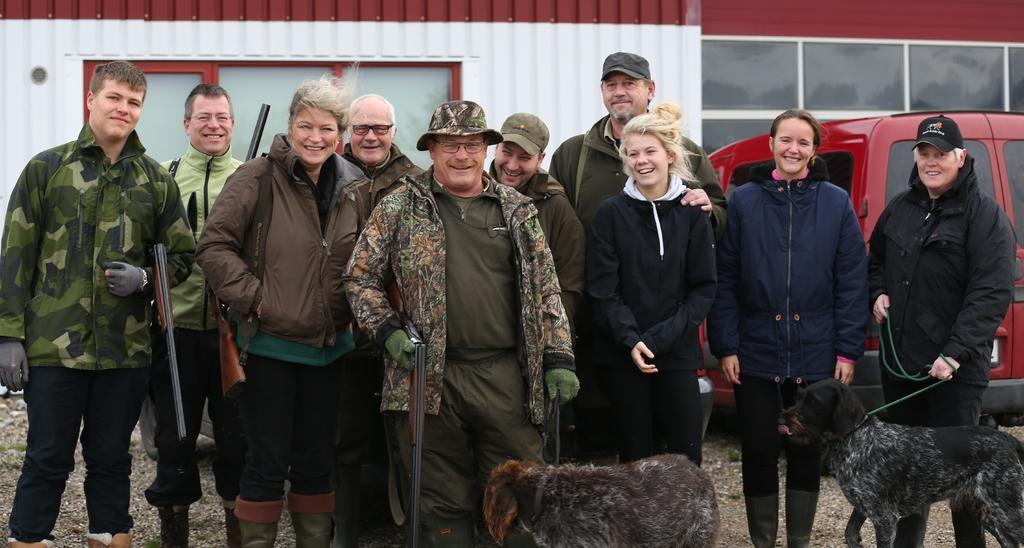Describe this image in one or two sentences. In this image In the middle there is a man he wears jacket, t shirt and trouser he is smiling. On the right there is a person. On the left there is a man he is smiling he wears jacket and trouser. In this image there are many people they are smiling, standing. At the bottom there are two dogs. In the background there is vehicle, window and glass. 